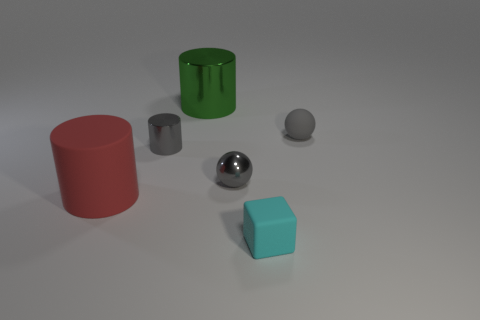The object that is to the right of the small matte thing that is in front of the red matte cylinder is what shape?
Keep it short and to the point. Sphere. Are there any other things that have the same color as the rubber sphere?
Offer a very short reply. Yes. Is the color of the matte sphere the same as the small shiny cylinder?
Ensure brevity in your answer.  Yes. What number of purple things are either cubes or big metallic things?
Your response must be concise. 0. Are there fewer gray metal spheres that are in front of the small gray cylinder than gray spheres?
Make the answer very short. Yes. There is a tiny rubber thing in front of the red matte thing; how many cyan matte blocks are behind it?
Ensure brevity in your answer.  0. How many other things are the same size as the red object?
Your answer should be very brief. 1. How many objects are either brown objects or tiny things that are to the right of the block?
Keep it short and to the point. 1. Are there fewer tiny shiny cylinders than tiny purple blocks?
Provide a short and direct response. No. There is a sphere to the right of the gray metal object on the right side of the large green cylinder; what is its color?
Your answer should be compact. Gray. 